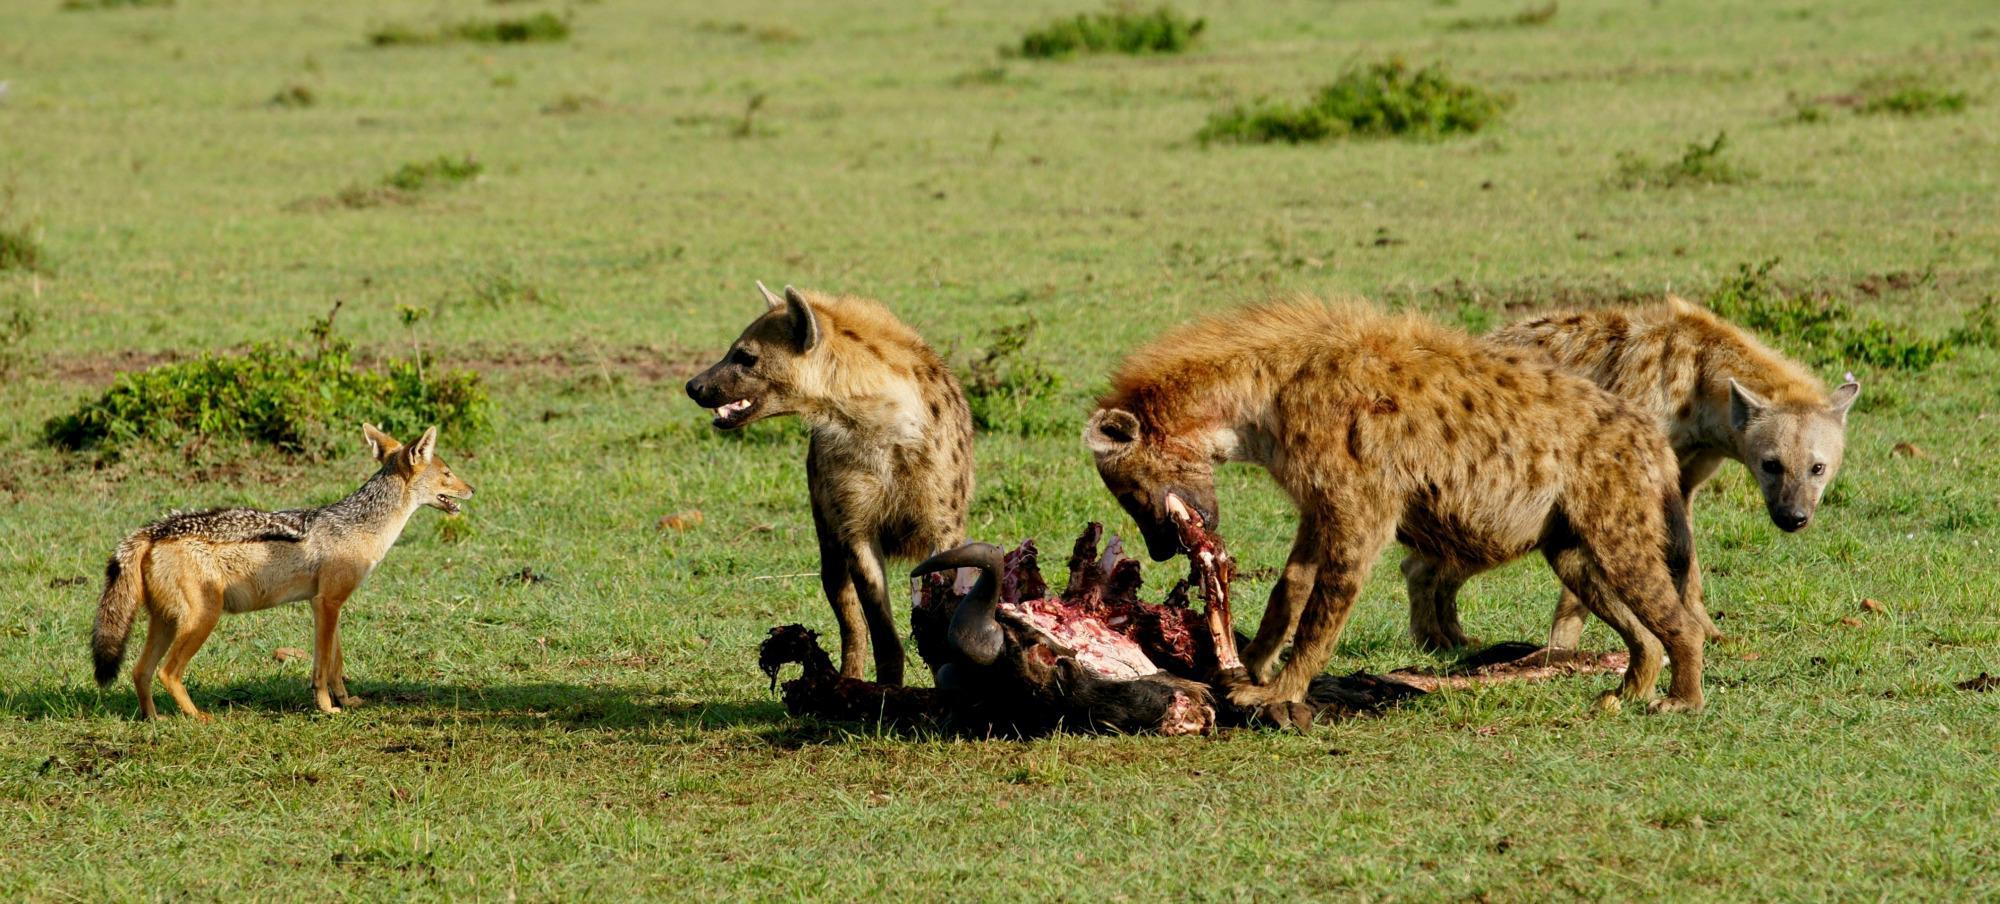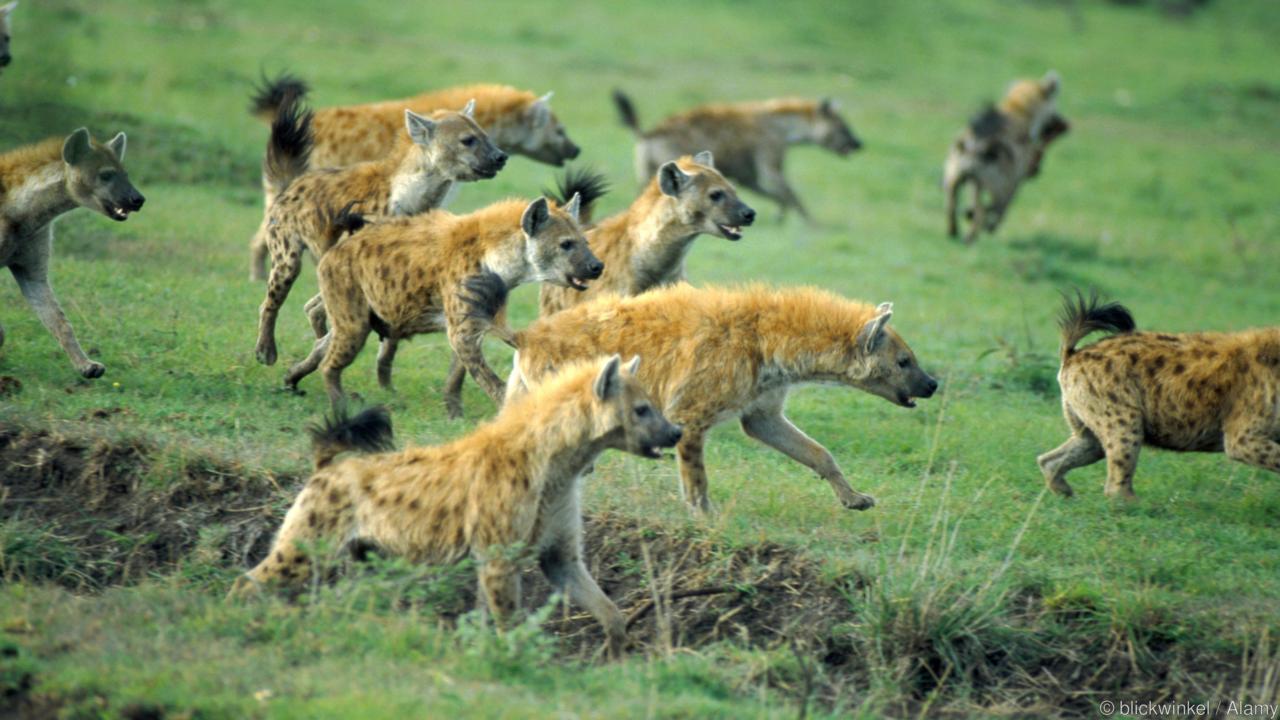The first image is the image on the left, the second image is the image on the right. Given the left and right images, does the statement "One of the images only contains hyenas" hold true? Answer yes or no. Yes. The first image is the image on the left, the second image is the image on the right. Given the left and right images, does the statement "One image shows hyenas around an open-mouthed lion." hold true? Answer yes or no. No. 